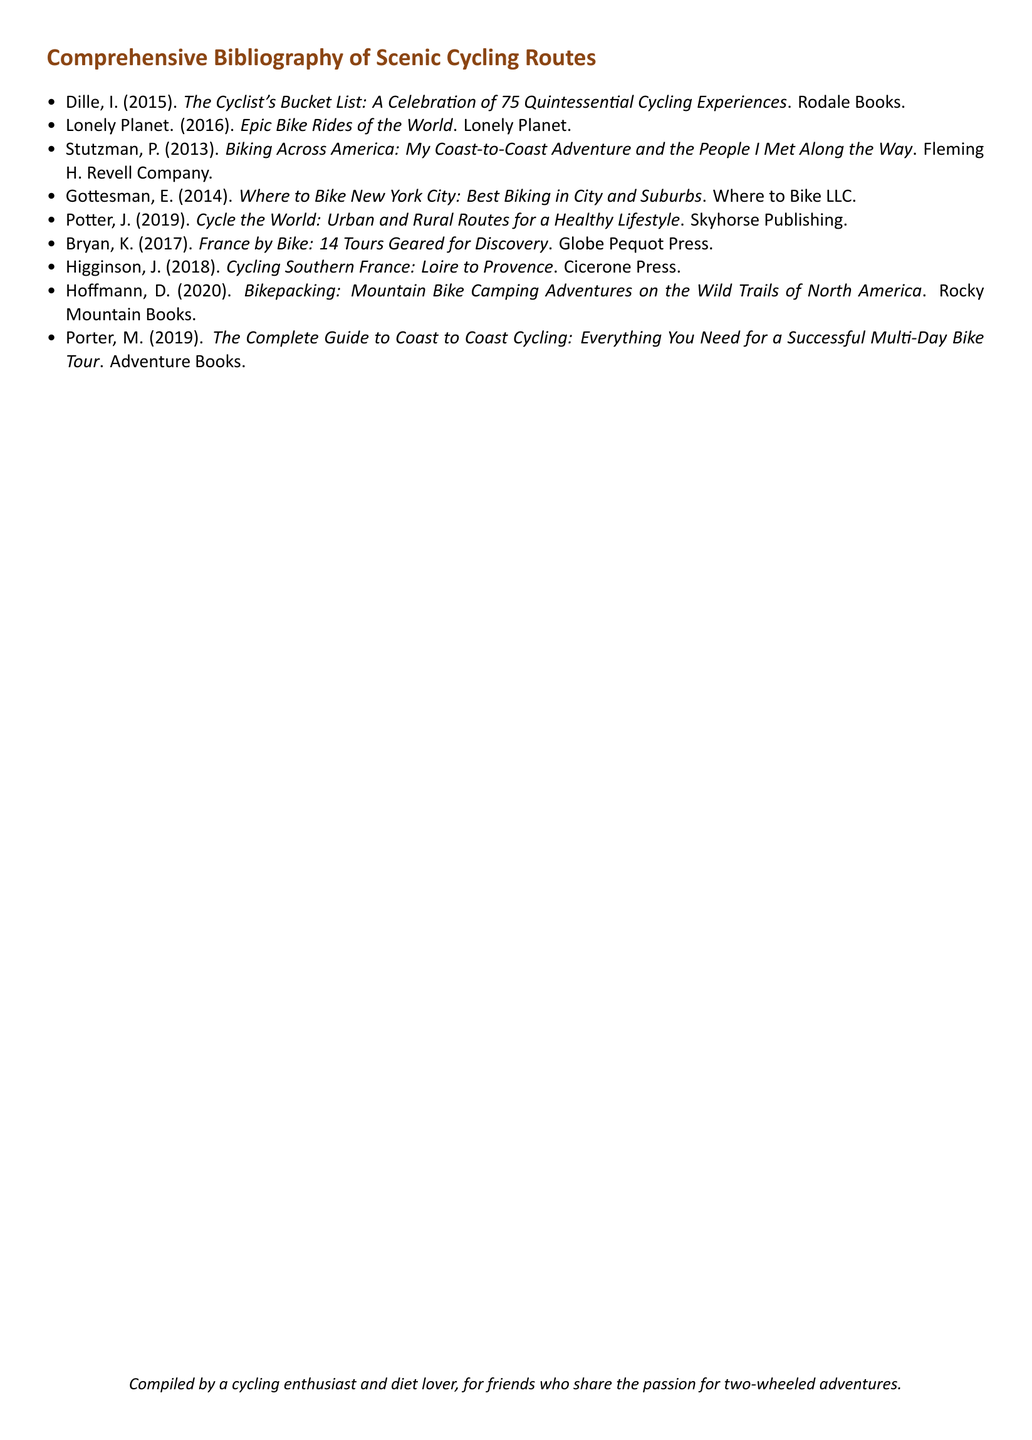What is the title of the first book listed? The first book listed is titled "The Cyclist's Bucket List: A Celebration of 75 Quintessential Cycling Experiences".
Answer: The Cyclist's Bucket List: A Celebration of 75 Quintessential Cycling Experiences Who is the author of "Epic Bike Rides of the World"? The author of "Epic Bike Rides of the World" is Lonely Planet.
Answer: Lonely Planet What year was "Biking Across America" published? "Biking Across America" was published in 2013.
Answer: 2013 How many authors contributed to this bibliography? There are a total of 9 authors listed in the bibliography.
Answer: 9 Which publisher released "Cycle the World"? "Cycle the World" was published by Skyhorse Publishing.
Answer: Skyhorse Publishing What is the theme of the bibliography? The theme focuses on scenic cycling routes around the world.
Answer: Scenic cycling routes What kind of adventures does "Bikepacking" refer to? "Bikepacking" refers to mountain bike camping adventures.
Answer: Mountain bike camping adventures What is the purpose of the document? The purpose of the document is to provide a comprehensive bibliography of scenic cycling routes.
Answer: Provide a comprehensive bibliography In what format is the document presented? The document is presented in a bibliography format.
Answer: Bibliography format 